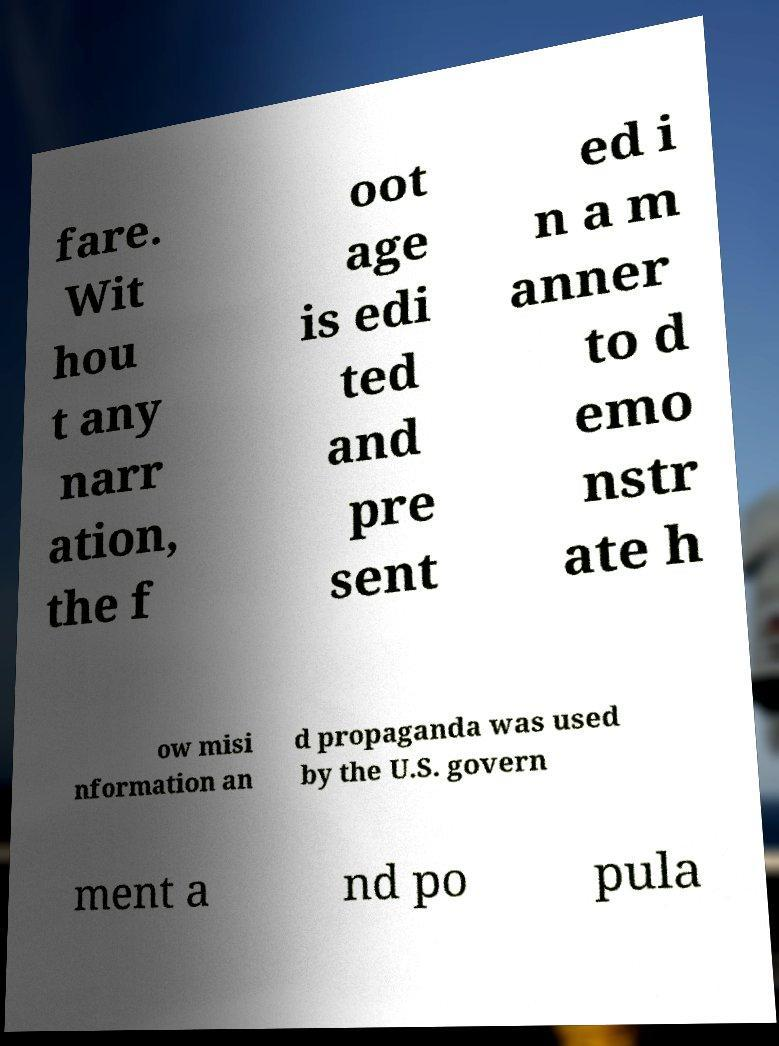Please identify and transcribe the text found in this image. fare. Wit hou t any narr ation, the f oot age is edi ted and pre sent ed i n a m anner to d emo nstr ate h ow misi nformation an d propaganda was used by the U.S. govern ment a nd po pula 